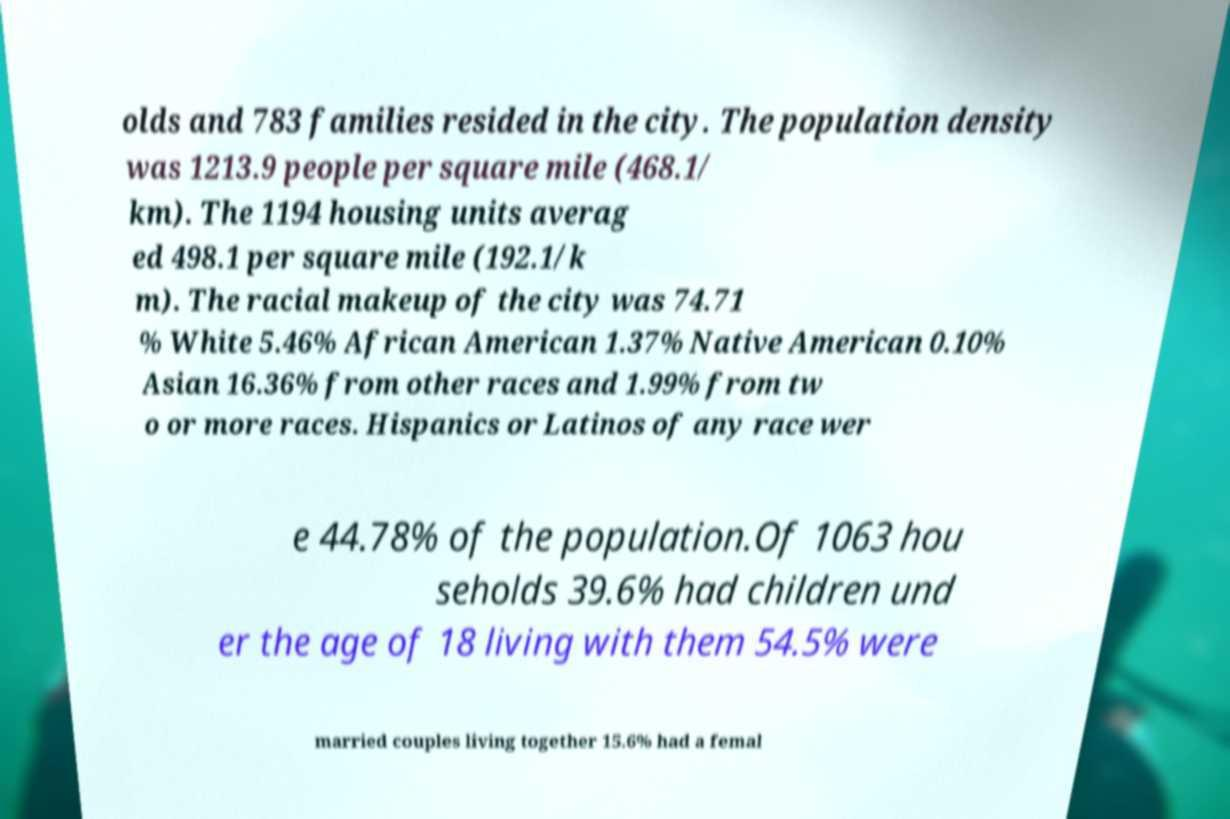Can you read and provide the text displayed in the image?This photo seems to have some interesting text. Can you extract and type it out for me? olds and 783 families resided in the city. The population density was 1213.9 people per square mile (468.1/ km). The 1194 housing units averag ed 498.1 per square mile (192.1/k m). The racial makeup of the city was 74.71 % White 5.46% African American 1.37% Native American 0.10% Asian 16.36% from other races and 1.99% from tw o or more races. Hispanics or Latinos of any race wer e 44.78% of the population.Of 1063 hou seholds 39.6% had children und er the age of 18 living with them 54.5% were married couples living together 15.6% had a femal 